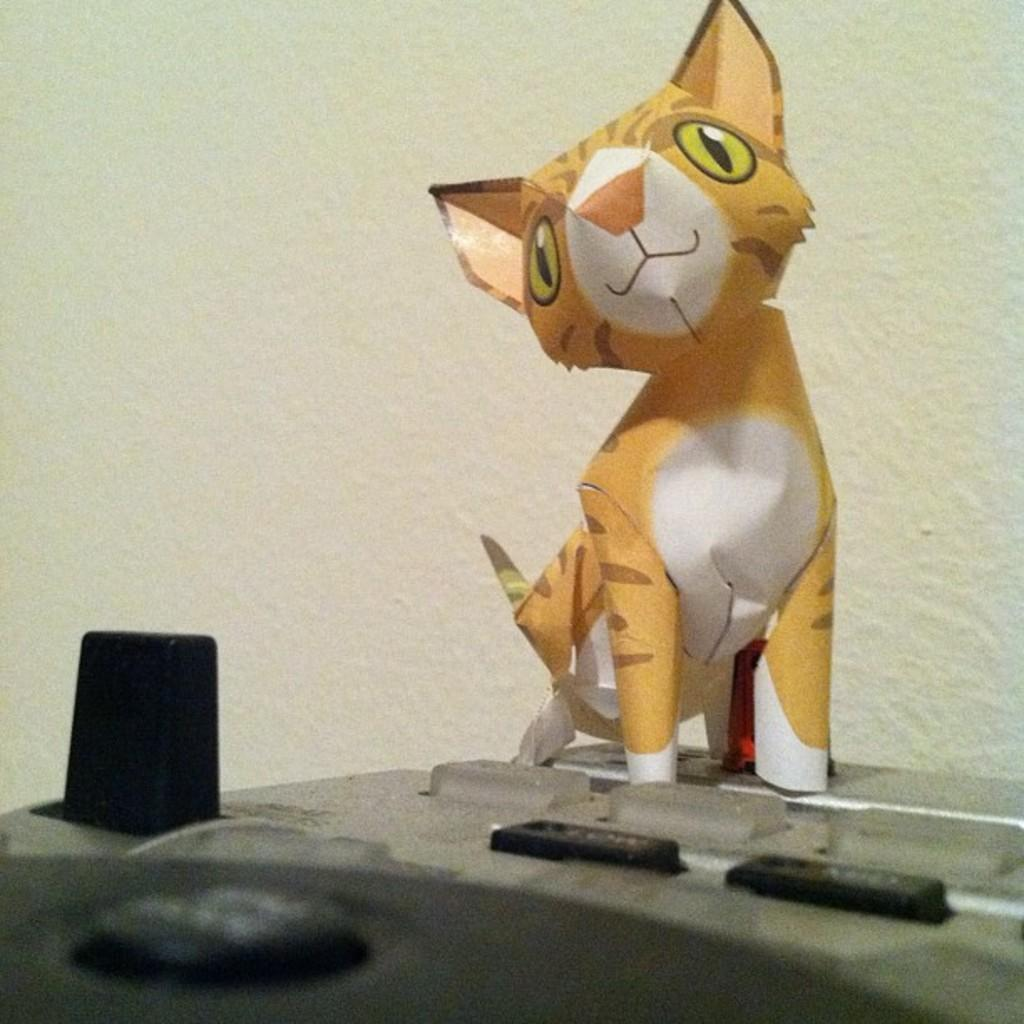What type of animal is depicted on the box in the image? There is a cartoon cat on a box in the image. What can be seen in the background of the image? There is a wall in the background of the image. What type of lock is used to secure the goose in the image? There is no goose or lock present in the image; it features a cartoon cat on a box with a wall in the background. 